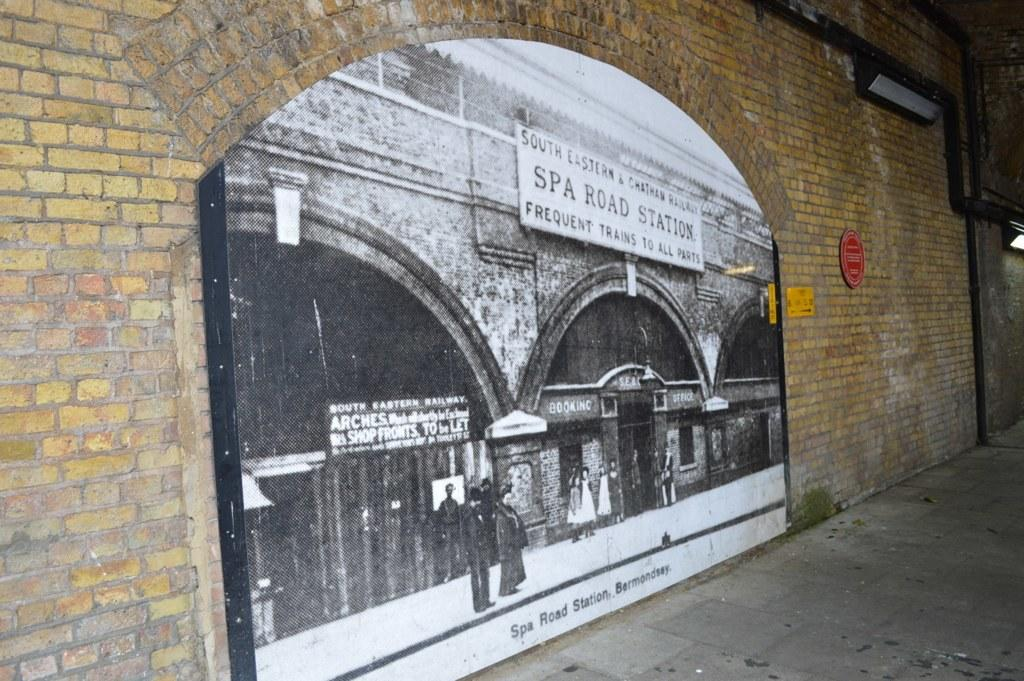What type of structure can be seen in the image? There is a wall in the image. What is hanging on the wall? There is a poster in the image. What is visible at the bottom of the image? There is a road at the bottom of the image. What type of slope is visible on the road in the image? There is no slope visible on the road in the image; it appears to be flat. How does the brake system work on the poster in the image? There is no brake system mentioned or depicted on the poster in the image. 